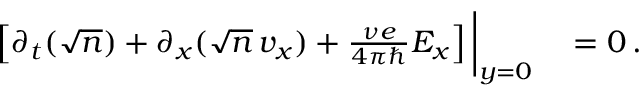Convert formula to latex. <formula><loc_0><loc_0><loc_500><loc_500>\begin{array} { r l } { \left [ \partial _ { t } ( \sqrt { n } ) + \partial _ { x } ( \sqrt { n } \, v _ { x } ) + \frac { \nu e } { 4 \pi } E _ { x } \right ] \Big | _ { y = 0 } } & = 0 \, . } \end{array}</formula> 